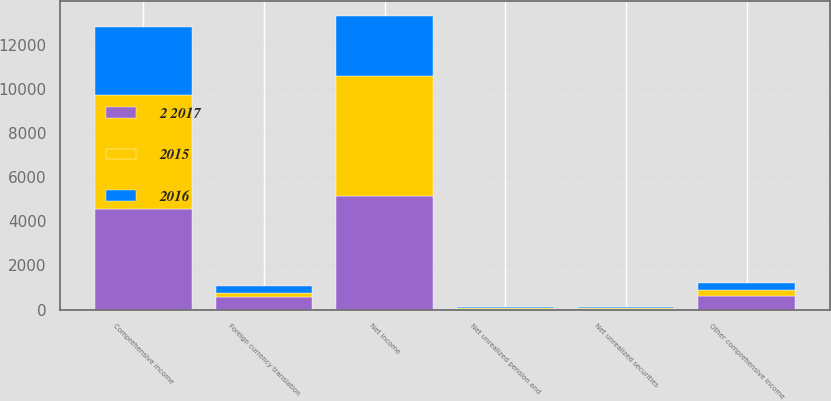<chart> <loc_0><loc_0><loc_500><loc_500><stacked_bar_chart><ecel><fcel>Net income<fcel>Net unrealized securities<fcel>Foreign currency translation<fcel>Net unrealized pension and<fcel>Other comprehensive income<fcel>Comprehensive income<nl><fcel>2016<fcel>2736<fcel>7<fcel>301<fcel>62<fcel>356<fcel>3092<nl><fcel>2015<fcel>5408<fcel>51<fcel>218<fcel>19<fcel>250<fcel>5158<nl><fcel>2 2017<fcel>5163<fcel>38<fcel>545<fcel>32<fcel>615<fcel>4548<nl></chart> 